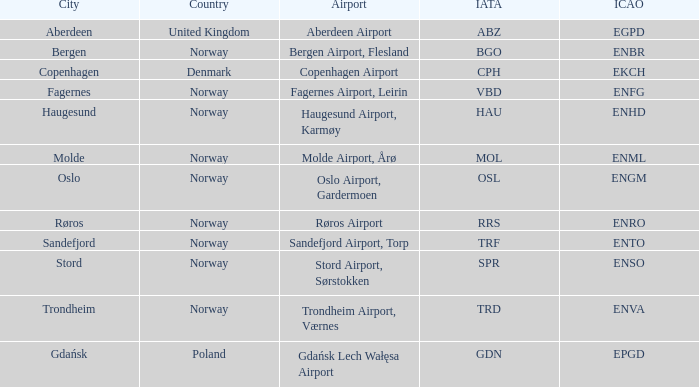What is City of Sandefjord in Norway's IATA? TRF. 